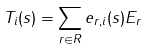Convert formula to latex. <formula><loc_0><loc_0><loc_500><loc_500>T _ { i } ( s ) = \sum _ { r \in R } e _ { r , i } ( s ) E _ { r }</formula> 